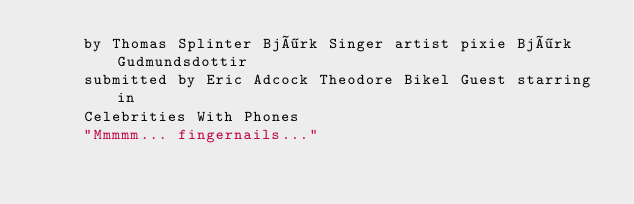<code> <loc_0><loc_0><loc_500><loc_500><_XML_>	 by Thomas Splinter Björk Singer artist pixie Björk Gudmundsdottir 
	 submitted by Eric Adcock Theodore Bikel Guest starring in 
	 Celebrities With Phones 
	 "Mmmmm... fingernails..." 
</code> 